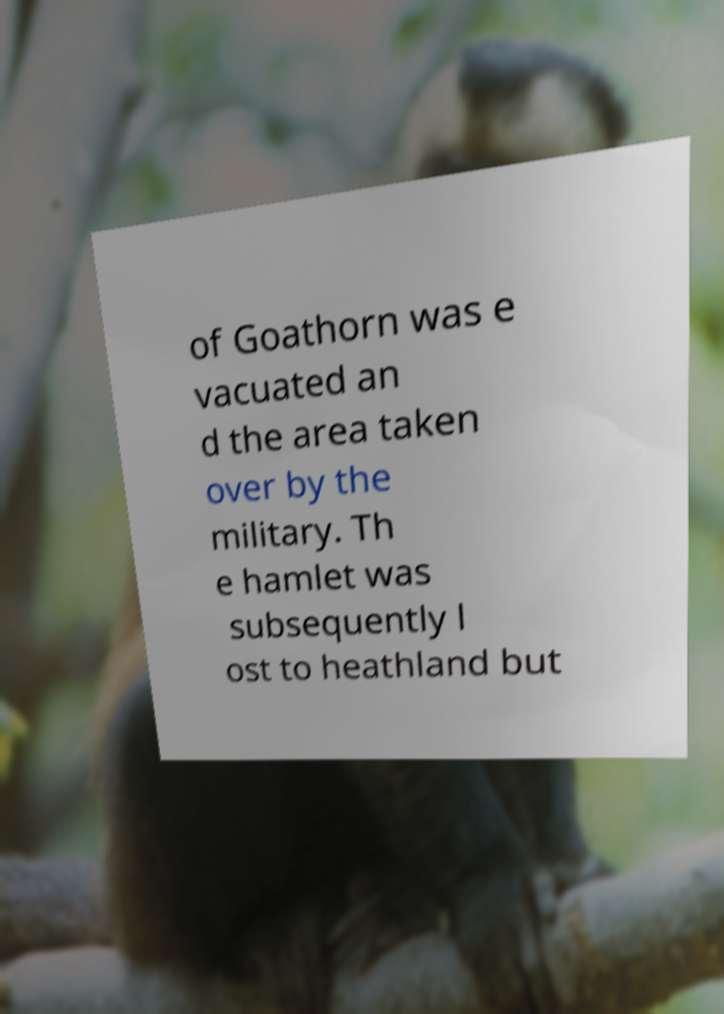Can you accurately transcribe the text from the provided image for me? of Goathorn was e vacuated an d the area taken over by the military. Th e hamlet was subsequently l ost to heathland but 